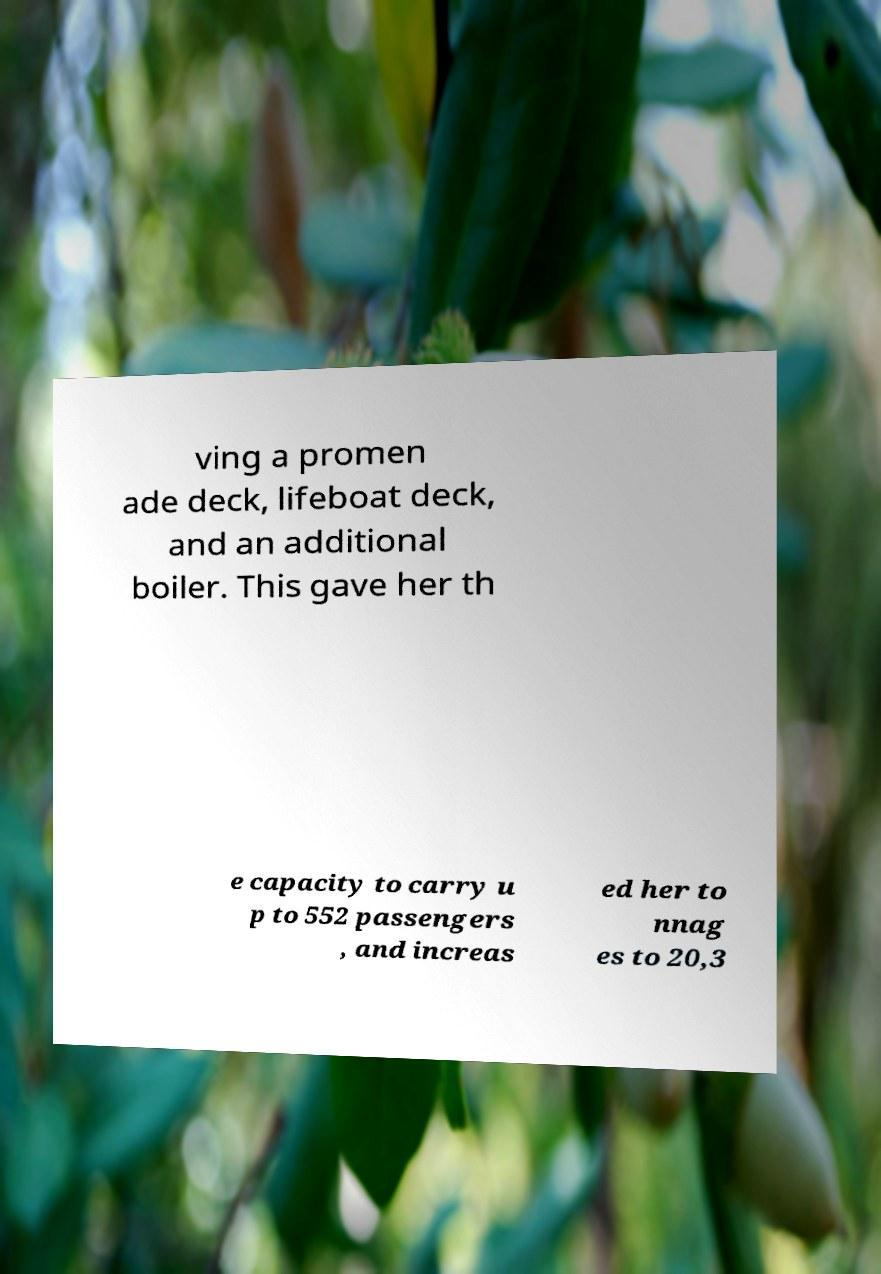Can you read and provide the text displayed in the image?This photo seems to have some interesting text. Can you extract and type it out for me? ving a promen ade deck, lifeboat deck, and an additional boiler. This gave her th e capacity to carry u p to 552 passengers , and increas ed her to nnag es to 20,3 